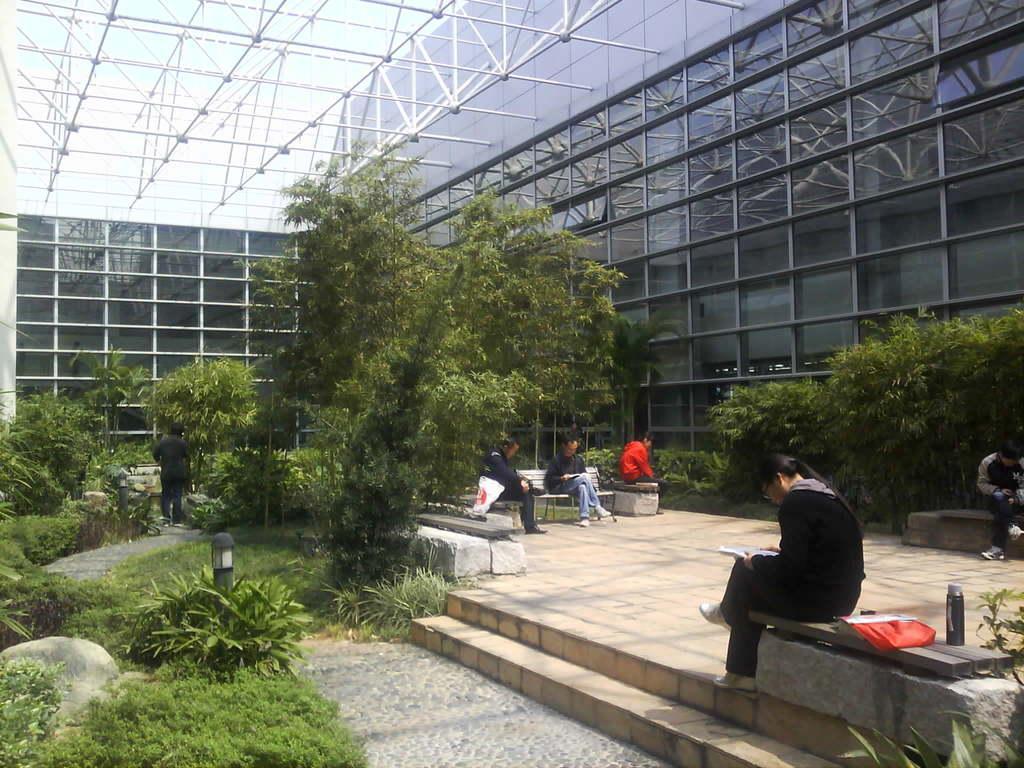Please provide a concise description of this image. In this image I see the building and I see few people who are sitting and I see the path and the steps over here and I can also see a person over here and I see the green grass, plants and the trees. In the background I see the iron rods and I see the sky. 